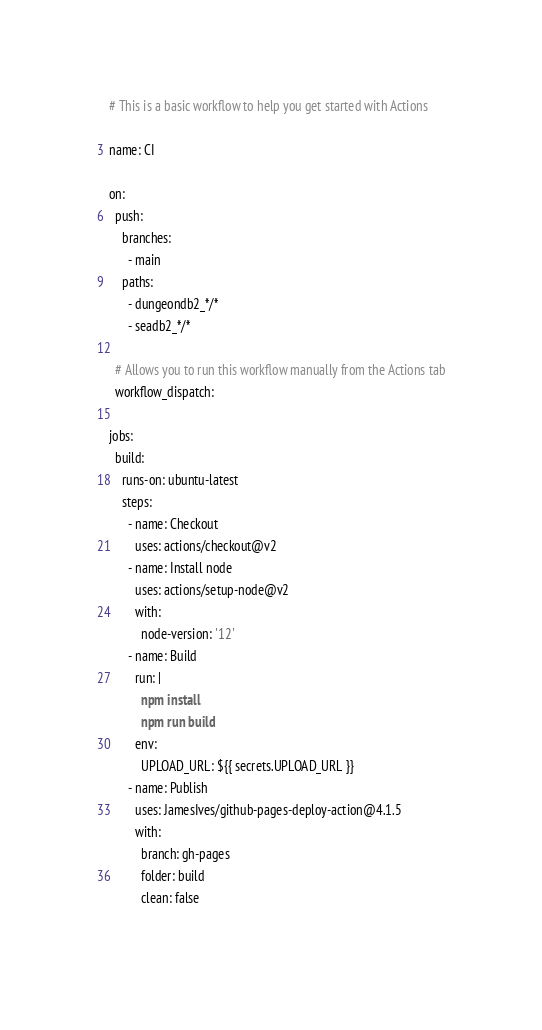<code> <loc_0><loc_0><loc_500><loc_500><_YAML_># This is a basic workflow to help you get started with Actions

name: CI

on:
  push:
    branches:
      - main
    paths:
      - dungeondb2_*/*
      - seadb2_*/*

  # Allows you to run this workflow manually from the Actions tab
  workflow_dispatch:

jobs:
  build:
    runs-on: ubuntu-latest
    steps:
      - name: Checkout
        uses: actions/checkout@v2
      - name: Install node
        uses: actions/setup-node@v2
        with:
          node-version: '12'
      - name: Build
        run: |
          npm install
          npm run build
        env:
          UPLOAD_URL: ${{ secrets.UPLOAD_URL }}
      - name: Publish
        uses: JamesIves/github-pages-deploy-action@4.1.5
        with:
          branch: gh-pages
          folder: build
          clean: false
  
</code> 